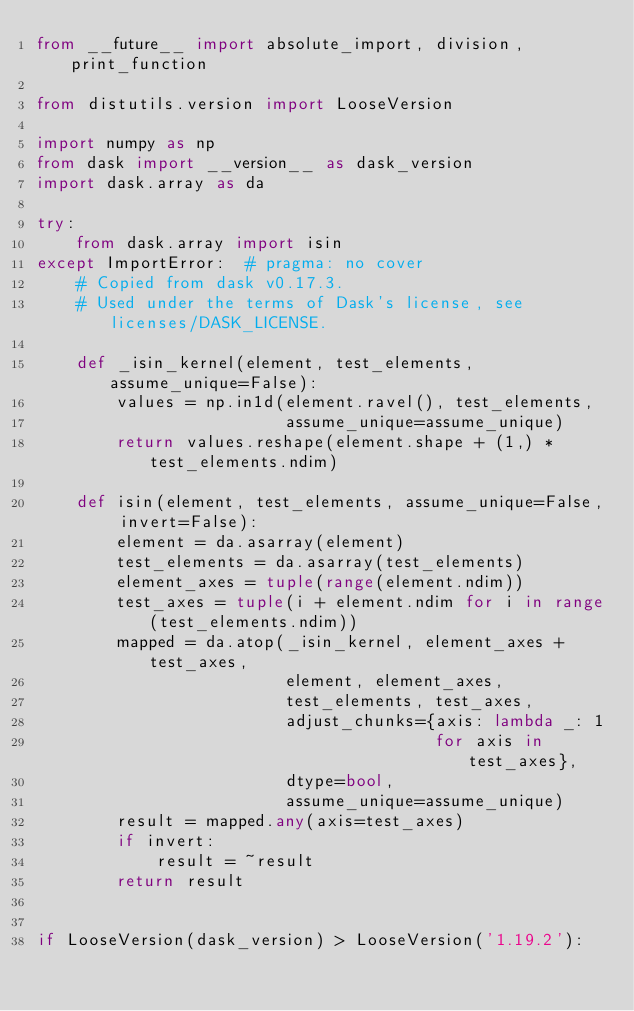<code> <loc_0><loc_0><loc_500><loc_500><_Python_>from __future__ import absolute_import, division, print_function

from distutils.version import LooseVersion

import numpy as np
from dask import __version__ as dask_version
import dask.array as da

try:
    from dask.array import isin
except ImportError:  # pragma: no cover
    # Copied from dask v0.17.3.
    # Used under the terms of Dask's license, see licenses/DASK_LICENSE.

    def _isin_kernel(element, test_elements, assume_unique=False):
        values = np.in1d(element.ravel(), test_elements,
                         assume_unique=assume_unique)
        return values.reshape(element.shape + (1,) * test_elements.ndim)

    def isin(element, test_elements, assume_unique=False, invert=False):
        element = da.asarray(element)
        test_elements = da.asarray(test_elements)
        element_axes = tuple(range(element.ndim))
        test_axes = tuple(i + element.ndim for i in range(test_elements.ndim))
        mapped = da.atop(_isin_kernel, element_axes + test_axes,
                         element, element_axes,
                         test_elements, test_axes,
                         adjust_chunks={axis: lambda _: 1
                                        for axis in test_axes},
                         dtype=bool,
                         assume_unique=assume_unique)
        result = mapped.any(axis=test_axes)
        if invert:
            result = ~result
        return result


if LooseVersion(dask_version) > LooseVersion('1.19.2'):</code> 